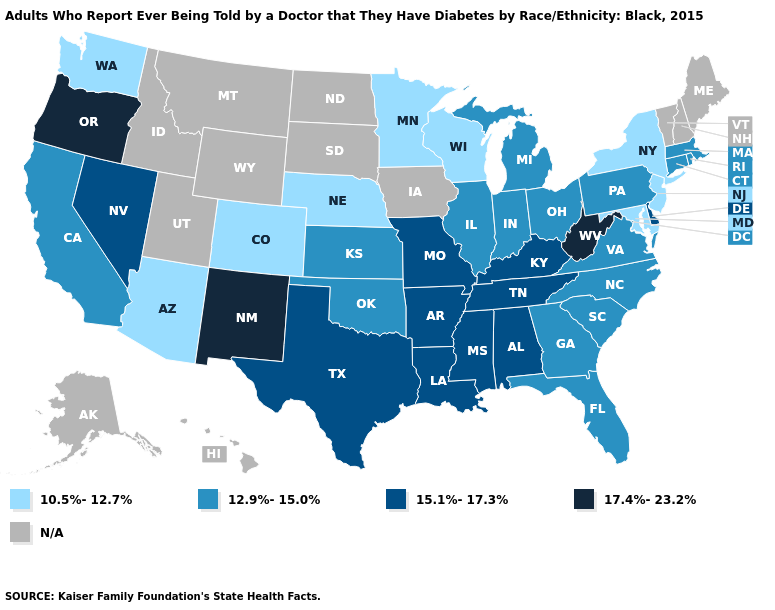Among the states that border Idaho , which have the lowest value?
Short answer required. Washington. What is the value of Minnesota?
Write a very short answer. 10.5%-12.7%. Does the map have missing data?
Answer briefly. Yes. What is the lowest value in the USA?
Write a very short answer. 10.5%-12.7%. Among the states that border North Carolina , does South Carolina have the lowest value?
Give a very brief answer. Yes. What is the value of Kentucky?
Quick response, please. 15.1%-17.3%. Name the states that have a value in the range 17.4%-23.2%?
Write a very short answer. New Mexico, Oregon, West Virginia. Does the map have missing data?
Keep it brief. Yes. Does the map have missing data?
Quick response, please. Yes. What is the value of Maryland?
Write a very short answer. 10.5%-12.7%. Does the first symbol in the legend represent the smallest category?
Be succinct. Yes. Name the states that have a value in the range 17.4%-23.2%?
Concise answer only. New Mexico, Oregon, West Virginia. Which states have the lowest value in the Northeast?
Keep it brief. New Jersey, New York. What is the value of Tennessee?
Concise answer only. 15.1%-17.3%. 